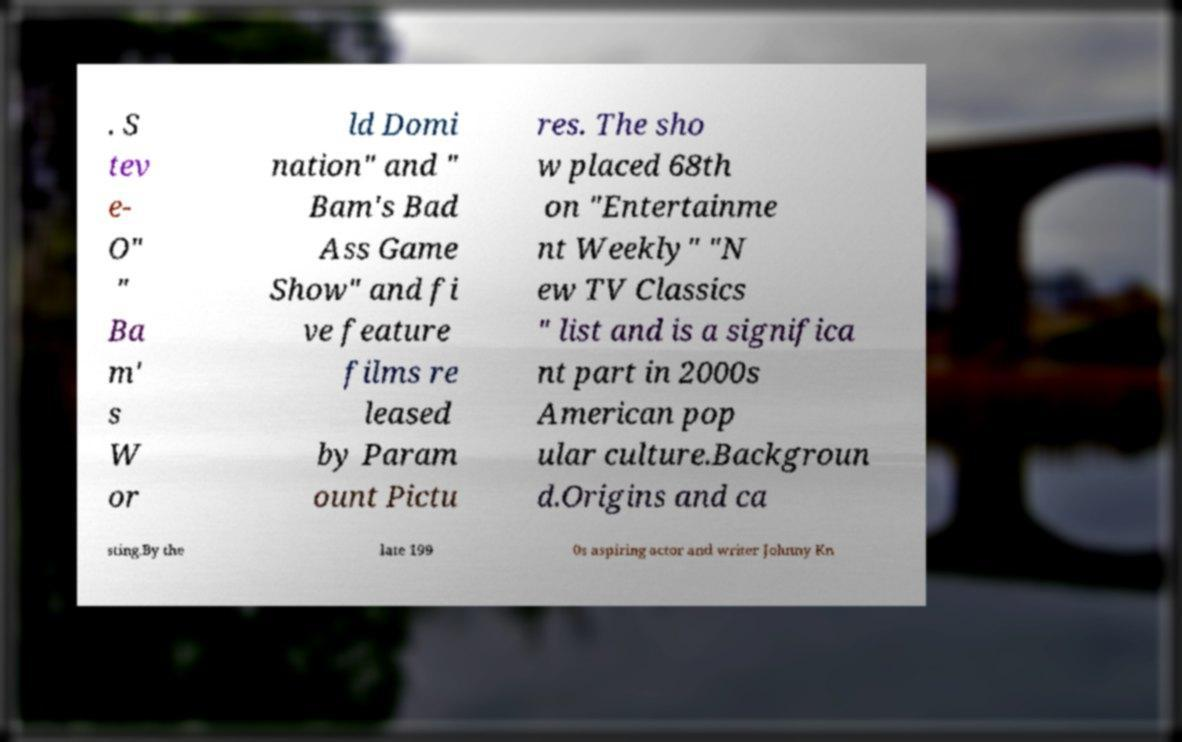For documentation purposes, I need the text within this image transcribed. Could you provide that? . S tev e- O" " Ba m' s W or ld Domi nation" and " Bam's Bad Ass Game Show" and fi ve feature films re leased by Param ount Pictu res. The sho w placed 68th on "Entertainme nt Weekly" "N ew TV Classics " list and is a significa nt part in 2000s American pop ular culture.Backgroun d.Origins and ca sting.By the late 199 0s aspiring actor and writer Johnny Kn 